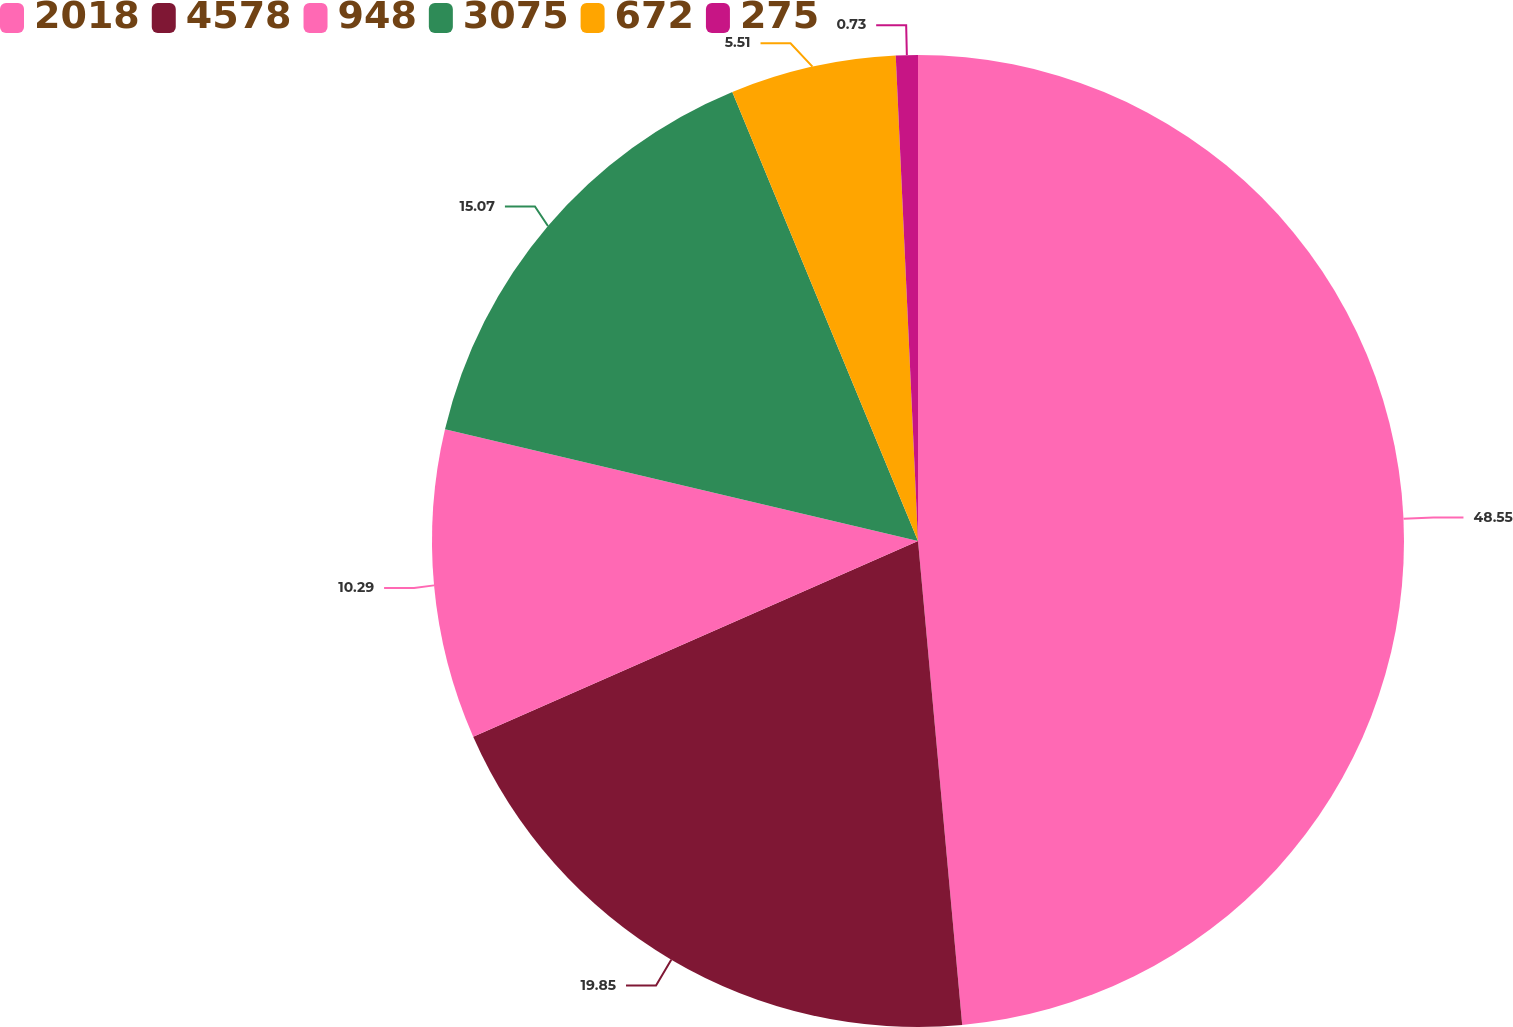<chart> <loc_0><loc_0><loc_500><loc_500><pie_chart><fcel>2018<fcel>4578<fcel>948<fcel>3075<fcel>672<fcel>275<nl><fcel>48.55%<fcel>19.85%<fcel>10.29%<fcel>15.07%<fcel>5.51%<fcel>0.73%<nl></chart> 